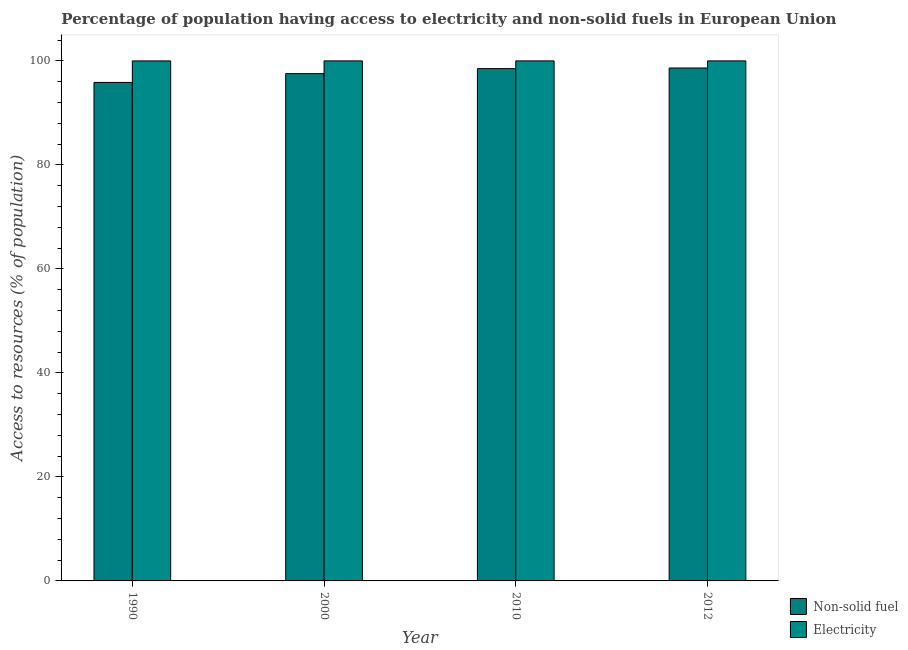How many groups of bars are there?
Provide a short and direct response. 4. Are the number of bars per tick equal to the number of legend labels?
Keep it short and to the point. Yes. Are the number of bars on each tick of the X-axis equal?
Give a very brief answer. Yes. What is the percentage of population having access to non-solid fuel in 2010?
Offer a very short reply. 98.51. Across all years, what is the minimum percentage of population having access to electricity?
Give a very brief answer. 99.99. In which year was the percentage of population having access to non-solid fuel minimum?
Provide a succinct answer. 1990. What is the total percentage of population having access to non-solid fuel in the graph?
Your response must be concise. 390.54. What is the difference between the percentage of population having access to electricity in 1990 and that in 2010?
Give a very brief answer. -0.01. What is the difference between the percentage of population having access to non-solid fuel in 1990 and the percentage of population having access to electricity in 2010?
Offer a terse response. -2.66. What is the average percentage of population having access to non-solid fuel per year?
Your answer should be compact. 97.64. In the year 2010, what is the difference between the percentage of population having access to electricity and percentage of population having access to non-solid fuel?
Ensure brevity in your answer.  0. What is the ratio of the percentage of population having access to electricity in 1990 to that in 2010?
Your response must be concise. 1. Is the percentage of population having access to electricity in 2010 less than that in 2012?
Offer a very short reply. No. Is the difference between the percentage of population having access to electricity in 2010 and 2012 greater than the difference between the percentage of population having access to non-solid fuel in 2010 and 2012?
Your answer should be compact. No. What is the difference between the highest and the second highest percentage of population having access to non-solid fuel?
Provide a succinct answer. 0.12. What is the difference between the highest and the lowest percentage of population having access to non-solid fuel?
Provide a short and direct response. 2.78. What does the 2nd bar from the left in 2012 represents?
Your answer should be very brief. Electricity. What does the 2nd bar from the right in 1990 represents?
Provide a short and direct response. Non-solid fuel. How many bars are there?
Ensure brevity in your answer.  8. How many years are there in the graph?
Provide a succinct answer. 4. What is the difference between two consecutive major ticks on the Y-axis?
Give a very brief answer. 20. Are the values on the major ticks of Y-axis written in scientific E-notation?
Give a very brief answer. No. How many legend labels are there?
Offer a terse response. 2. What is the title of the graph?
Offer a very short reply. Percentage of population having access to electricity and non-solid fuels in European Union. Does "From human activities" appear as one of the legend labels in the graph?
Offer a terse response. No. What is the label or title of the X-axis?
Your response must be concise. Year. What is the label or title of the Y-axis?
Give a very brief answer. Access to resources (% of population). What is the Access to resources (% of population) of Non-solid fuel in 1990?
Provide a succinct answer. 95.85. What is the Access to resources (% of population) of Electricity in 1990?
Offer a terse response. 99.99. What is the Access to resources (% of population) of Non-solid fuel in 2000?
Provide a succinct answer. 97.55. What is the Access to resources (% of population) of Electricity in 2000?
Ensure brevity in your answer.  100. What is the Access to resources (% of population) in Non-solid fuel in 2010?
Provide a succinct answer. 98.51. What is the Access to resources (% of population) in Electricity in 2010?
Provide a succinct answer. 100. What is the Access to resources (% of population) in Non-solid fuel in 2012?
Offer a terse response. 98.63. Across all years, what is the maximum Access to resources (% of population) in Non-solid fuel?
Offer a very short reply. 98.63. Across all years, what is the minimum Access to resources (% of population) of Non-solid fuel?
Give a very brief answer. 95.85. Across all years, what is the minimum Access to resources (% of population) of Electricity?
Offer a very short reply. 99.99. What is the total Access to resources (% of population) in Non-solid fuel in the graph?
Provide a succinct answer. 390.54. What is the total Access to resources (% of population) of Electricity in the graph?
Ensure brevity in your answer.  399.99. What is the difference between the Access to resources (% of population) in Non-solid fuel in 1990 and that in 2000?
Provide a succinct answer. -1.69. What is the difference between the Access to resources (% of population) in Electricity in 1990 and that in 2000?
Your answer should be very brief. -0.01. What is the difference between the Access to resources (% of population) in Non-solid fuel in 1990 and that in 2010?
Offer a very short reply. -2.66. What is the difference between the Access to resources (% of population) of Electricity in 1990 and that in 2010?
Make the answer very short. -0.01. What is the difference between the Access to resources (% of population) of Non-solid fuel in 1990 and that in 2012?
Provide a short and direct response. -2.78. What is the difference between the Access to resources (% of population) in Electricity in 1990 and that in 2012?
Ensure brevity in your answer.  -0.01. What is the difference between the Access to resources (% of population) of Non-solid fuel in 2000 and that in 2010?
Keep it short and to the point. -0.96. What is the difference between the Access to resources (% of population) in Non-solid fuel in 2000 and that in 2012?
Your answer should be very brief. -1.09. What is the difference between the Access to resources (% of population) in Non-solid fuel in 2010 and that in 2012?
Offer a terse response. -0.12. What is the difference between the Access to resources (% of population) of Electricity in 2010 and that in 2012?
Your answer should be very brief. 0. What is the difference between the Access to resources (% of population) in Non-solid fuel in 1990 and the Access to resources (% of population) in Electricity in 2000?
Offer a terse response. -4.15. What is the difference between the Access to resources (% of population) in Non-solid fuel in 1990 and the Access to resources (% of population) in Electricity in 2010?
Provide a short and direct response. -4.15. What is the difference between the Access to resources (% of population) of Non-solid fuel in 1990 and the Access to resources (% of population) of Electricity in 2012?
Provide a short and direct response. -4.15. What is the difference between the Access to resources (% of population) of Non-solid fuel in 2000 and the Access to resources (% of population) of Electricity in 2010?
Keep it short and to the point. -2.45. What is the difference between the Access to resources (% of population) in Non-solid fuel in 2000 and the Access to resources (% of population) in Electricity in 2012?
Provide a short and direct response. -2.45. What is the difference between the Access to resources (% of population) of Non-solid fuel in 2010 and the Access to resources (% of population) of Electricity in 2012?
Provide a succinct answer. -1.49. What is the average Access to resources (% of population) of Non-solid fuel per year?
Your answer should be compact. 97.64. What is the average Access to resources (% of population) of Electricity per year?
Offer a very short reply. 100. In the year 1990, what is the difference between the Access to resources (% of population) of Non-solid fuel and Access to resources (% of population) of Electricity?
Give a very brief answer. -4.14. In the year 2000, what is the difference between the Access to resources (% of population) in Non-solid fuel and Access to resources (% of population) in Electricity?
Your answer should be compact. -2.45. In the year 2010, what is the difference between the Access to resources (% of population) in Non-solid fuel and Access to resources (% of population) in Electricity?
Offer a terse response. -1.49. In the year 2012, what is the difference between the Access to resources (% of population) in Non-solid fuel and Access to resources (% of population) in Electricity?
Provide a short and direct response. -1.37. What is the ratio of the Access to resources (% of population) in Non-solid fuel in 1990 to that in 2000?
Offer a terse response. 0.98. What is the ratio of the Access to resources (% of population) of Electricity in 1990 to that in 2000?
Offer a terse response. 1. What is the ratio of the Access to resources (% of population) of Non-solid fuel in 1990 to that in 2010?
Give a very brief answer. 0.97. What is the ratio of the Access to resources (% of population) in Electricity in 1990 to that in 2010?
Ensure brevity in your answer.  1. What is the ratio of the Access to resources (% of population) in Non-solid fuel in 1990 to that in 2012?
Your response must be concise. 0.97. What is the ratio of the Access to resources (% of population) of Non-solid fuel in 2000 to that in 2010?
Your answer should be compact. 0.99. What is the ratio of the Access to resources (% of population) in Electricity in 2000 to that in 2012?
Offer a terse response. 1. What is the ratio of the Access to resources (% of population) of Electricity in 2010 to that in 2012?
Offer a terse response. 1. What is the difference between the highest and the second highest Access to resources (% of population) of Non-solid fuel?
Give a very brief answer. 0.12. What is the difference between the highest and the second highest Access to resources (% of population) in Electricity?
Ensure brevity in your answer.  0. What is the difference between the highest and the lowest Access to resources (% of population) of Non-solid fuel?
Give a very brief answer. 2.78. What is the difference between the highest and the lowest Access to resources (% of population) in Electricity?
Offer a very short reply. 0.01. 